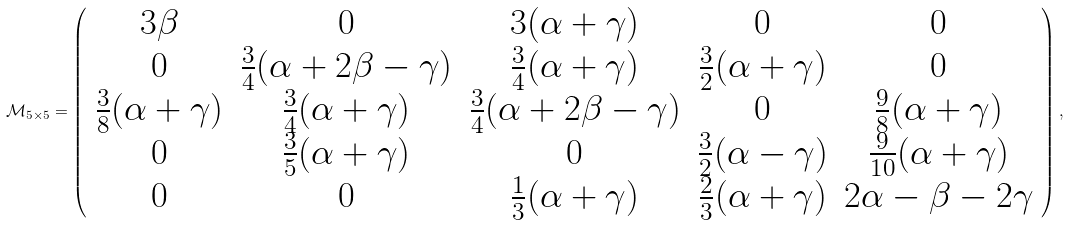Convert formula to latex. <formula><loc_0><loc_0><loc_500><loc_500>\mathcal { M } _ { 5 \times 5 } = \left ( \begin{array} [ c ] { c c c c c } 3 \beta & 0 & 3 ( \alpha + \gamma ) & 0 & 0 \\ 0 & \frac { 3 } { 4 } ( \alpha + 2 \beta - \gamma ) & \frac { 3 } { 4 } ( \alpha + \gamma ) & \frac { 3 } { 2 } ( \alpha + \gamma ) & 0 \\ \frac { 3 } { 8 } ( \alpha + \gamma ) & \frac { 3 } { 4 } ( \alpha + \gamma ) & \frac { 3 } { 4 } ( \alpha + 2 \beta - \gamma ) & 0 & \frac { 9 } { 8 } ( \alpha + \gamma ) \\ 0 & \frac { 3 } { 5 } ( \alpha + \gamma ) & 0 & \frac { 3 } { 2 } ( \alpha - \gamma ) & \frac { 9 } { 1 0 } ( \alpha + \gamma ) \\ 0 & 0 & \frac { 1 } { 3 } ( \alpha + \gamma ) & \frac { 2 } { 3 } ( \alpha + \gamma ) & 2 \alpha - \beta - 2 \gamma \end{array} \right ) ,</formula> 